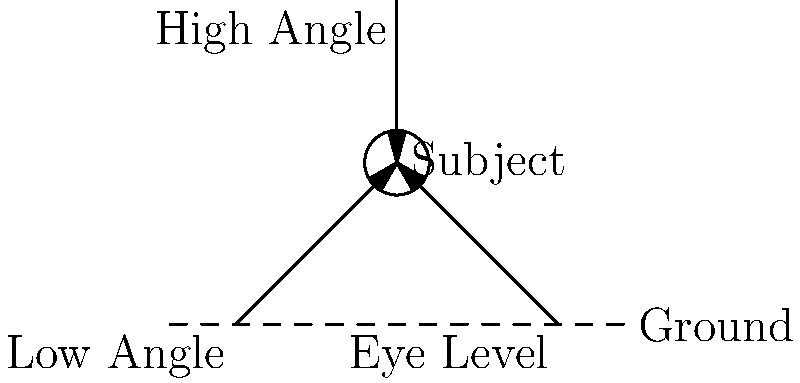In Isabel Coixet's film "My Life Without Me," which camera angle is often used to convey the protagonist's vulnerability and sense of being overwhelmed by her circumstances? To answer this question, let's analyze the camera angles shown in the diagram and their typical uses in cinema:

1. Low Angle: This angle is shot from below the subject, looking up. It typically makes the subject appear more powerful, dominant, or intimidating.

2. Eye Level: This is a neutral angle, shot at the same level as the subject's eyes. It's often used for normal dialogue scenes or to create a sense of equality between the viewer and the subject.

3. High Angle: This angle is shot from above the subject, looking down. It's frequently used to make the subject appear smaller, vulnerable, or overwhelmed by their environment.

In "My Life Without Me," Isabel Coixet often explores themes of mortality, vulnerability, and the protagonist's struggle with her terminal diagnosis. To convey these emotions and the character's sense of being overwhelmed by her circumstances, Coixet would likely employ high angle shots.

High angle shots visually diminish the subject, making them appear smaller in the frame. This technique aligns with the film's narrative, where the protagonist, Ann, is grappling with the enormity of her situation and the limited time she has left.

Therefore, the high angle would be the most appropriate choice to convey the protagonist's vulnerability and sense of being overwhelmed in "My Life Without Me."
Answer: High Angle 